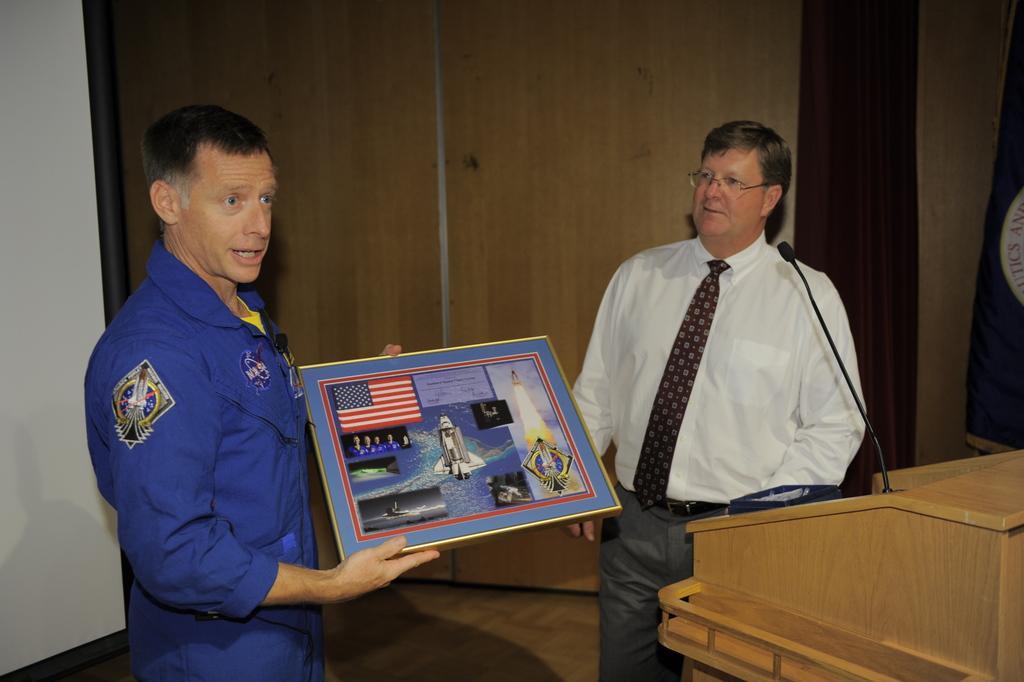Describe this image in one or two sentences. In the picture I can see a person wearing blue dress is standing and holding a photo frame in the left corner and there is a person wearing white shirt is standing in the right corner and there is a wooden stand which has a mic placed on it is beside him. 